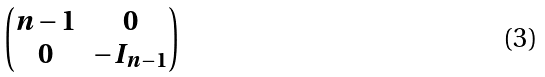<formula> <loc_0><loc_0><loc_500><loc_500>\begin{pmatrix} n - 1 & 0 \\ 0 & - I _ { n - 1 } \end{pmatrix}</formula> 